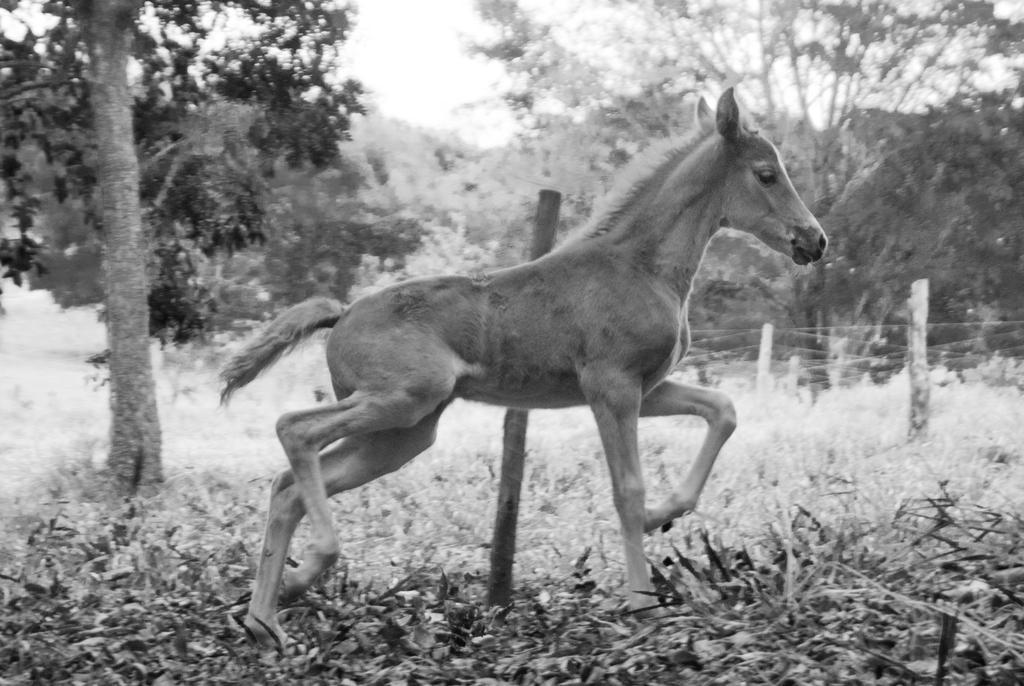Could you give a brief overview of what you see in this image? In the picture I can see an animal. In the background I can see the sky, trees, fence, plants and some other objects. This picture is black and white in color. 